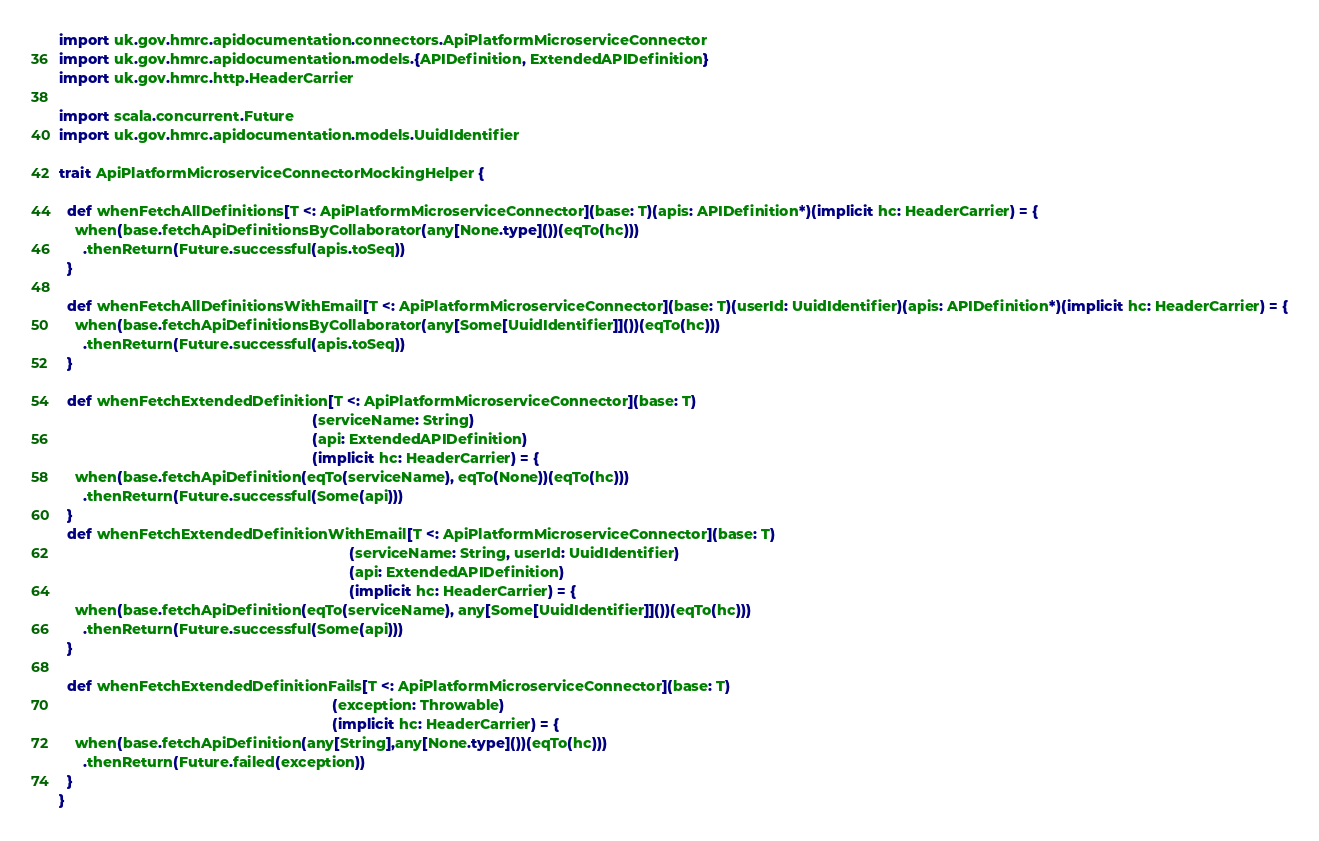<code> <loc_0><loc_0><loc_500><loc_500><_Scala_>import uk.gov.hmrc.apidocumentation.connectors.ApiPlatformMicroserviceConnector
import uk.gov.hmrc.apidocumentation.models.{APIDefinition, ExtendedAPIDefinition}
import uk.gov.hmrc.http.HeaderCarrier

import scala.concurrent.Future
import uk.gov.hmrc.apidocumentation.models.UuidIdentifier

trait ApiPlatformMicroserviceConnectorMockingHelper {

  def whenFetchAllDefinitions[T <: ApiPlatformMicroserviceConnector](base: T)(apis: APIDefinition*)(implicit hc: HeaderCarrier) = {
    when(base.fetchApiDefinitionsByCollaborator(any[None.type]())(eqTo(hc)))
      .thenReturn(Future.successful(apis.toSeq))
  }

  def whenFetchAllDefinitionsWithEmail[T <: ApiPlatformMicroserviceConnector](base: T)(userId: UuidIdentifier)(apis: APIDefinition*)(implicit hc: HeaderCarrier) = {
    when(base.fetchApiDefinitionsByCollaborator(any[Some[UuidIdentifier]]())(eqTo(hc)))
      .thenReturn(Future.successful(apis.toSeq))
  }

  def whenFetchExtendedDefinition[T <: ApiPlatformMicroserviceConnector](base: T)
                                                              (serviceName: String)
                                                              (api: ExtendedAPIDefinition)
                                                              (implicit hc: HeaderCarrier) = {
    when(base.fetchApiDefinition(eqTo(serviceName), eqTo(None))(eqTo(hc)))
      .thenReturn(Future.successful(Some(api)))
  }
  def whenFetchExtendedDefinitionWithEmail[T <: ApiPlatformMicroserviceConnector](base: T)
                                                                       (serviceName: String, userId: UuidIdentifier)
                                                                       (api: ExtendedAPIDefinition)
                                                                       (implicit hc: HeaderCarrier) = {
    when(base.fetchApiDefinition(eqTo(serviceName), any[Some[UuidIdentifier]]())(eqTo(hc)))
      .thenReturn(Future.successful(Some(api)))
  }

  def whenFetchExtendedDefinitionFails[T <: ApiPlatformMicroserviceConnector](base: T)
                                                                   (exception: Throwable)
                                                                   (implicit hc: HeaderCarrier) = {
    when(base.fetchApiDefinition(any[String],any[None.type]())(eqTo(hc)))
      .thenReturn(Future.failed(exception))
  }
}
</code> 